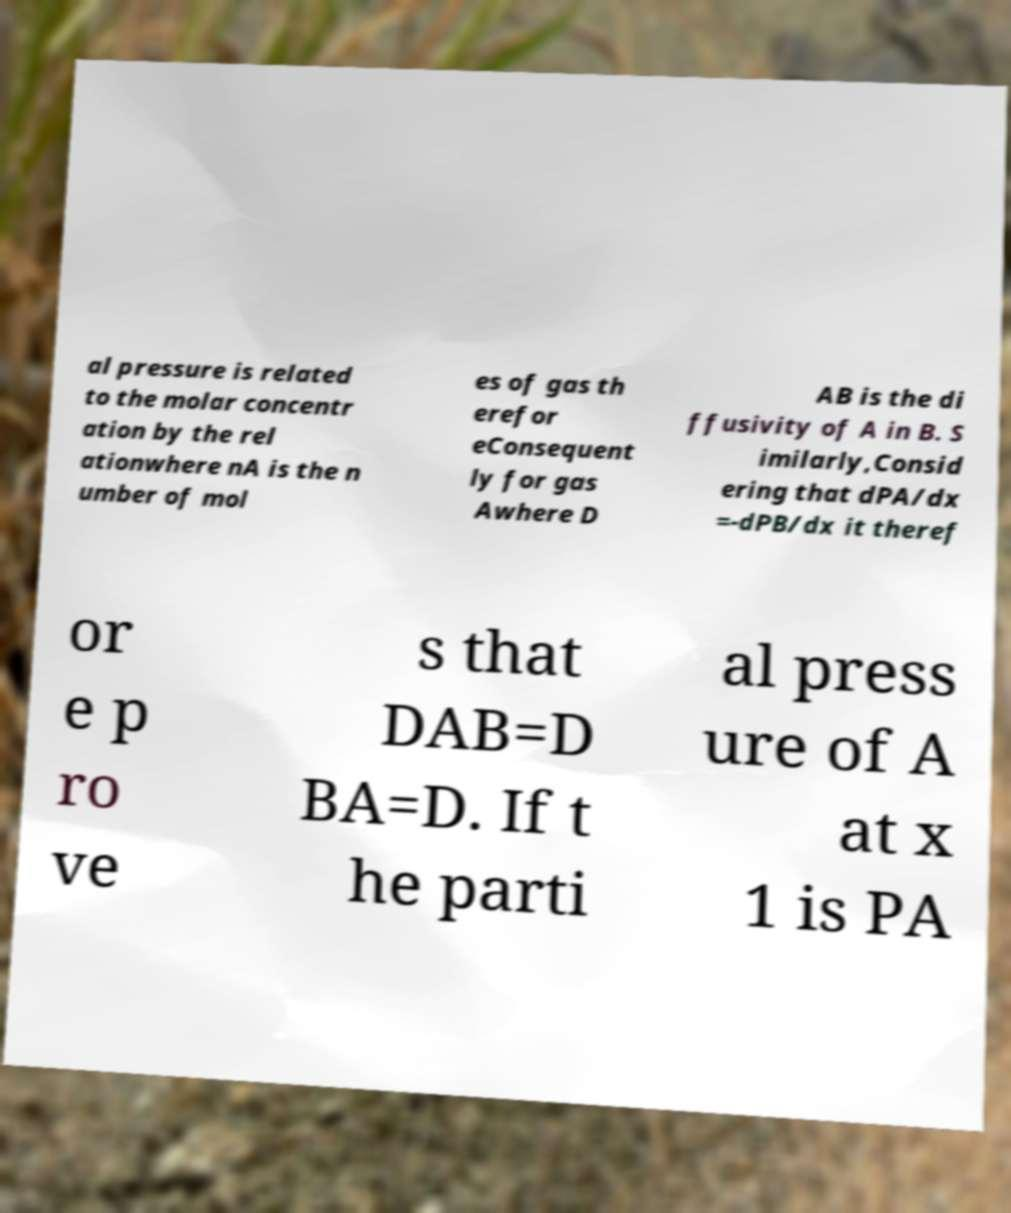Could you extract and type out the text from this image? al pressure is related to the molar concentr ation by the rel ationwhere nA is the n umber of mol es of gas th erefor eConsequent ly for gas Awhere D AB is the di ffusivity of A in B. S imilarly,Consid ering that dPA/dx =-dPB/dx it theref or e p ro ve s that DAB=D BA=D. If t he parti al press ure of A at x 1 is PA 